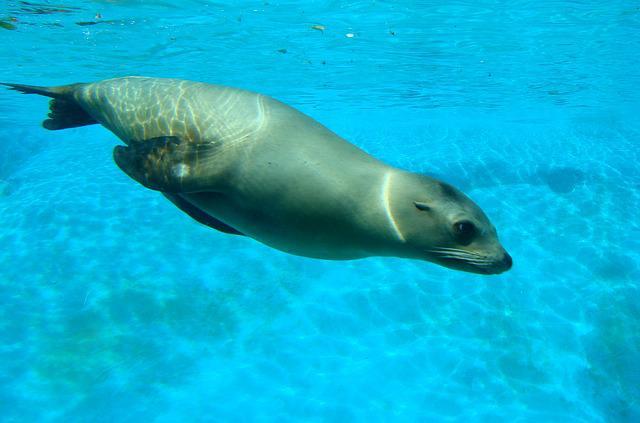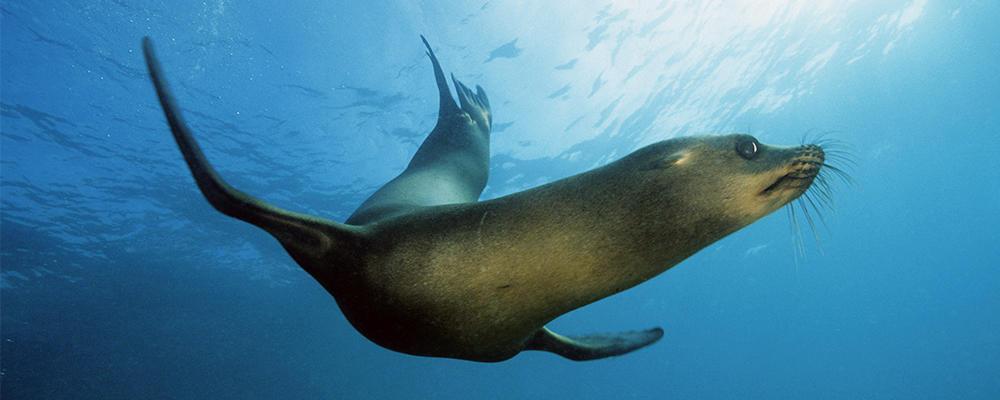The first image is the image on the left, the second image is the image on the right. Evaluate the accuracy of this statement regarding the images: "Blue water is visible in both images of seals.". Is it true? Answer yes or no. Yes. The first image is the image on the left, the second image is the image on the right. Assess this claim about the two images: "One image shows a seal on sand without water clearly visible.". Correct or not? Answer yes or no. No. 